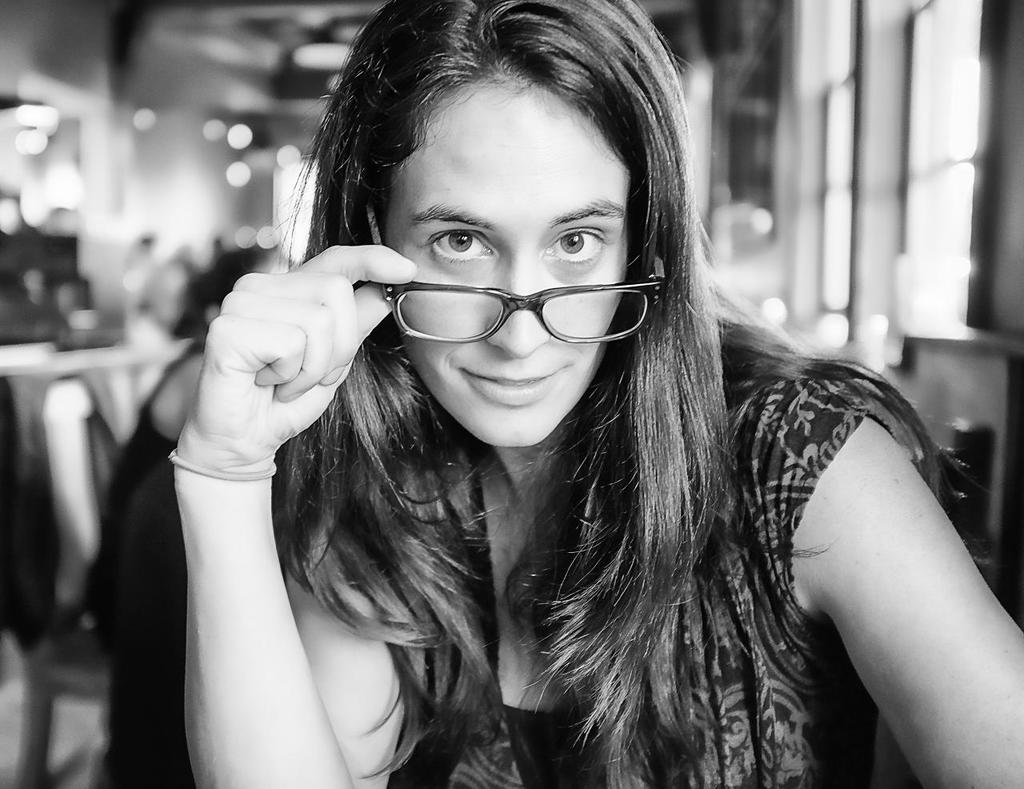What is the main subject of the image? The main subject of the image is a woman. What is the woman doing in the image? The woman is smiling in the image. Can you describe the background of the image? The background of the image is blurry. What type of sugar is the woman using to write her name in the image? There is no sugar present in the image, and the woman is not writing her name. What is the woman's occupation as a writer in the image? There is no indication in the image that the woman is a writer or has any occupation related to writing. 